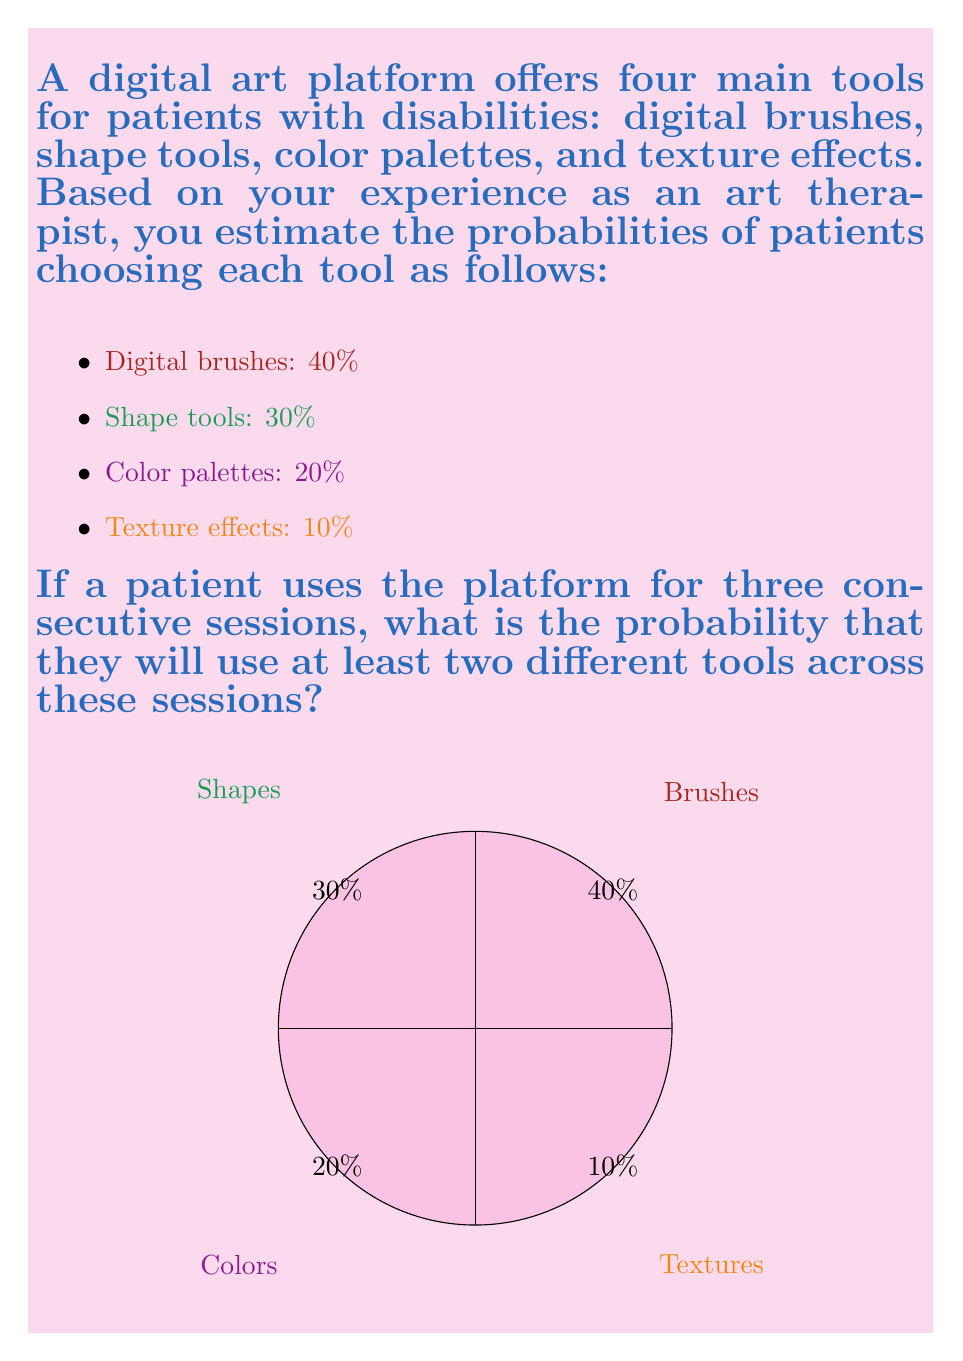Give your solution to this math problem. Let's approach this step-by-step:

1) First, we need to calculate the probability of using the same tool in all three sessions. This is the complement of what we're looking for.

2) The probability of using the same tool in all three sessions is the sum of the probabilities for each tool:

   $P(\text{same tool}) = 0.4^3 + 0.3^3 + 0.2^3 + 0.1^3$

3) Let's calculate each term:
   
   $0.4^3 = 0.064$
   $0.3^3 = 0.027$
   $0.2^3 = 0.008$
   $0.1^3 = 0.001$

4) Sum these up:

   $P(\text{same tool}) = 0.064 + 0.027 + 0.008 + 0.001 = 0.1$

5) The probability we're looking for is the complement of this:

   $P(\text{at least two different tools}) = 1 - P(\text{same tool}) = 1 - 0.1 = 0.9$

6) Therefore, the probability of using at least two different tools across three sessions is 0.9 or 90%.
Answer: $0.9$ or $90\%$ 